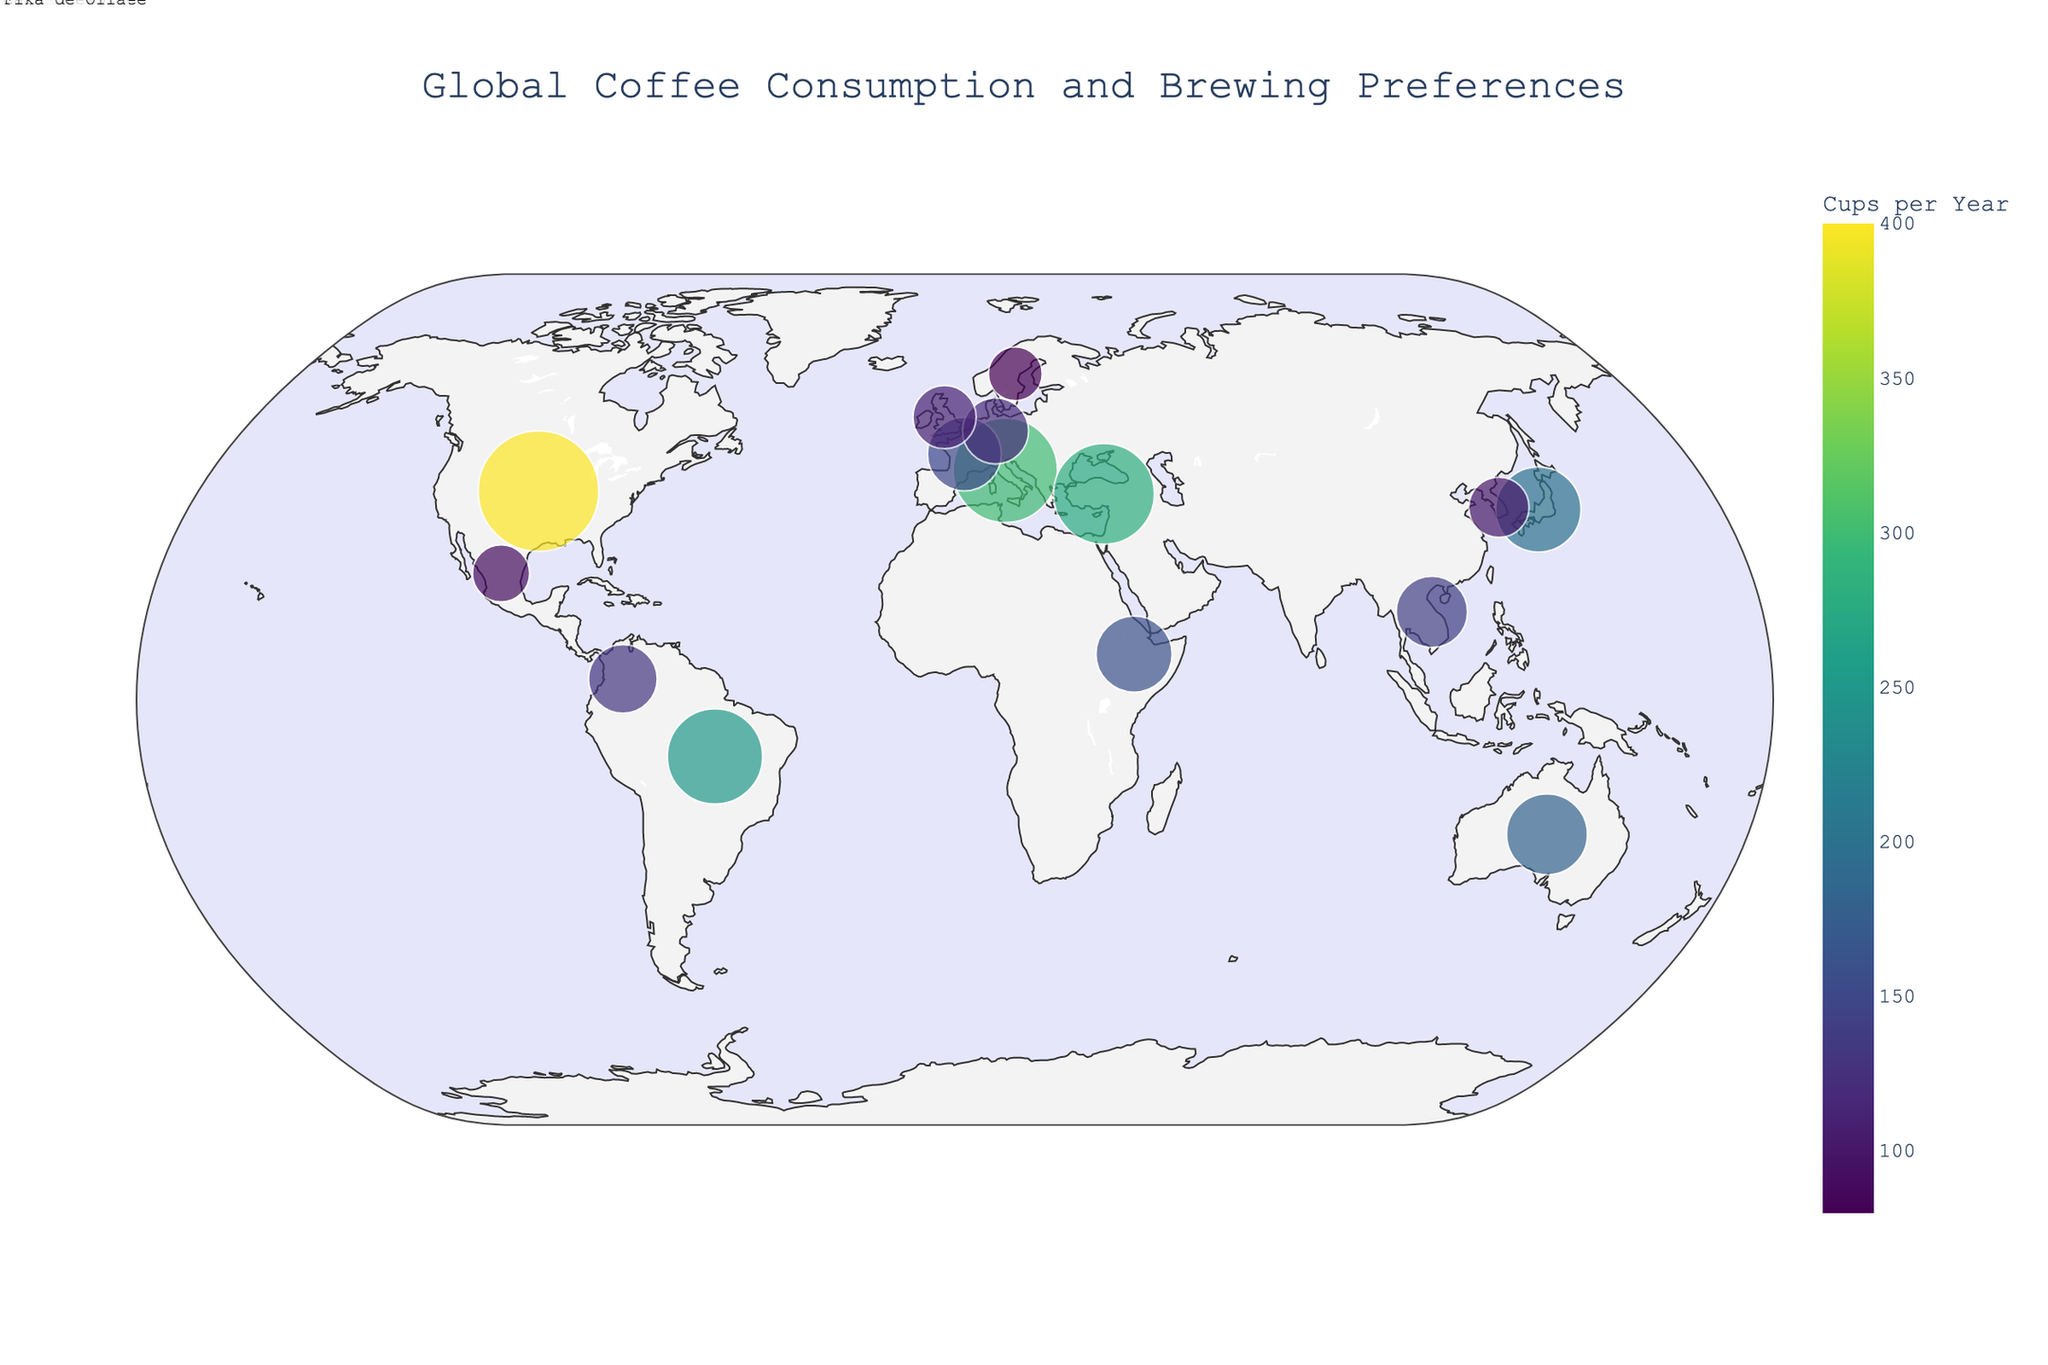What is the title of the figure? The title is displayed prominently at the top center of the figure in larger font size.
Answer: Global Coffee Consumption and Brewing Preferences Which country has the highest coffee consumption per capita? Look for the country with the largest dot size and darkest color, as larger dots and darker colors represent higher consumption.
Answer: United States What is the preferred brewing method in Japan? Hover over Japan, or look for Japan's annotation on the figure that specifies the brewing method.
Answer: Pour-over How does coffee consumption in France compare to that in Germany? Look at the annotations and sizes/colors of dots representing France and Germany. France has a slightly larger dot and darker color compared to Germany, indicating higher consumption.
Answer: France has higher consumption than Germany What is the total coffee consumption per capita for countries in Europe? Sum the consumption values for Italy (300), France (150), Germany (120), and United Kingdom (110).
Answer: 680 How does the consumption in Brazil compare to that in Colombia? Compare the dot size and color for Brazil and Colombia; Brazil has a larger dot and darker color, indicating higher consumption.
Answer: Brazil has higher consumption than Colombia What brewing method is preferred in South Korea? Hover over South Korea, or look for South Korea's annotation on the figure that specifies the brewing method.
Answer: Cold Brew Which region has the country with the lowest coffee consumption per capita? Find the country with the smallest dot and lightest color and identify its region.
Answer: Sweden (Europe) How many countries in the figure prefer a traditional or region-specific brewing method, not including common modern methods like Drip or Instant Coffee? Count countries with unique or traditional brewing methods: Turkey (Turkish Coffee), Brazil (Cafezinho), Ethiopia (Jebena), Mexico (Café de Olla), Vietnam (Phin Filter), Colombia (Tinto).
Answer: 6 What is the average coffee consumption per capita in North America? Sum the consumption values for the United States (400) and Mexico (90), then divide by the number of countries (2).
Answer: 245 